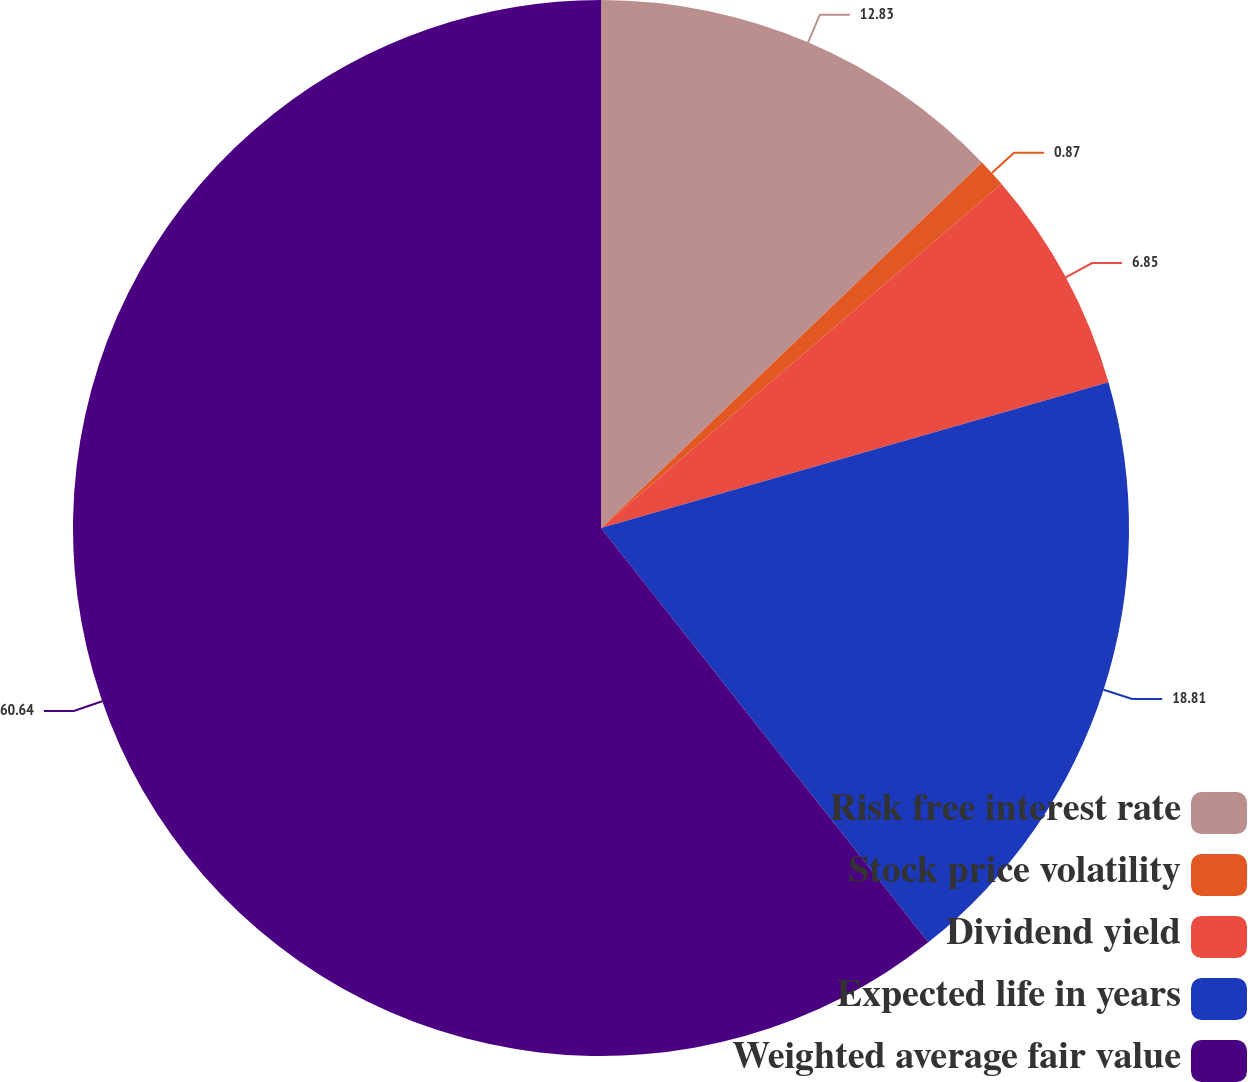Convert chart. <chart><loc_0><loc_0><loc_500><loc_500><pie_chart><fcel>Risk free interest rate<fcel>Stock price volatility<fcel>Dividend yield<fcel>Expected life in years<fcel>Weighted average fair value<nl><fcel>12.83%<fcel>0.87%<fcel>6.85%<fcel>18.81%<fcel>60.64%<nl></chart> 